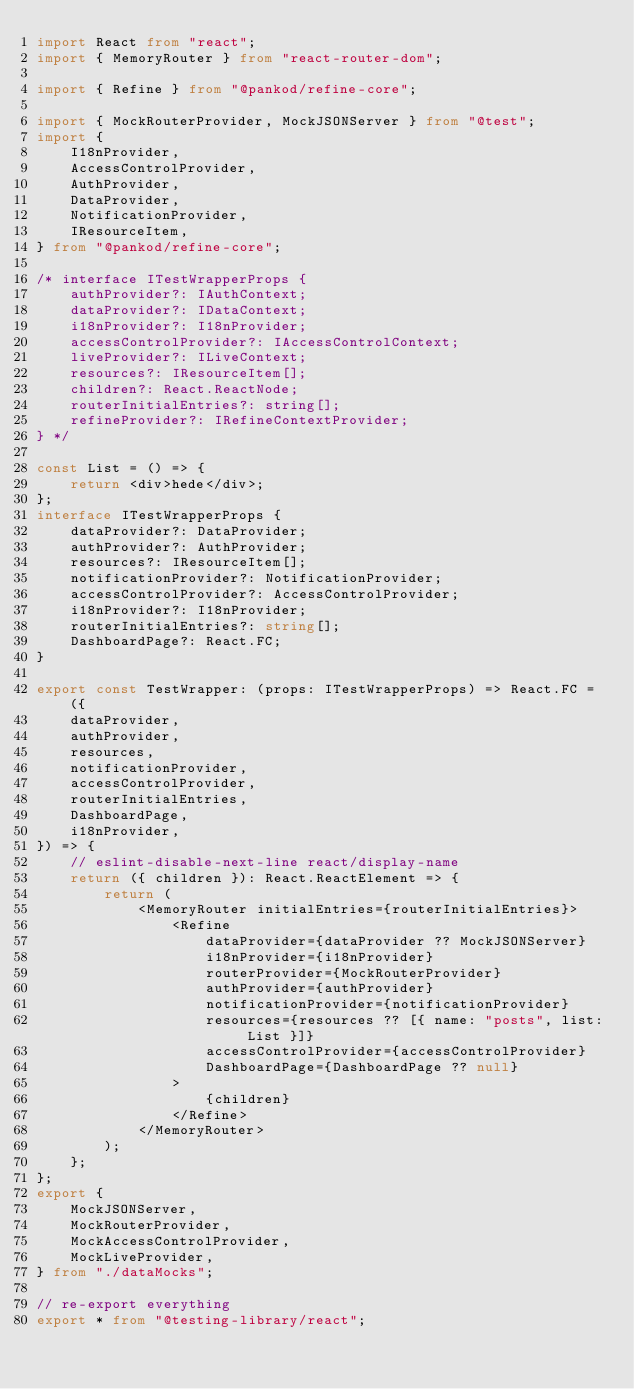<code> <loc_0><loc_0><loc_500><loc_500><_TypeScript_>import React from "react";
import { MemoryRouter } from "react-router-dom";

import { Refine } from "@pankod/refine-core";

import { MockRouterProvider, MockJSONServer } from "@test";
import {
    I18nProvider,
    AccessControlProvider,
    AuthProvider,
    DataProvider,
    NotificationProvider,
    IResourceItem,
} from "@pankod/refine-core";

/* interface ITestWrapperProps {
    authProvider?: IAuthContext;
    dataProvider?: IDataContext;
    i18nProvider?: I18nProvider;
    accessControlProvider?: IAccessControlContext;
    liveProvider?: ILiveContext;
    resources?: IResourceItem[];
    children?: React.ReactNode;
    routerInitialEntries?: string[];
    refineProvider?: IRefineContextProvider;
} */

const List = () => {
    return <div>hede</div>;
};
interface ITestWrapperProps {
    dataProvider?: DataProvider;
    authProvider?: AuthProvider;
    resources?: IResourceItem[];
    notificationProvider?: NotificationProvider;
    accessControlProvider?: AccessControlProvider;
    i18nProvider?: I18nProvider;
    routerInitialEntries?: string[];
    DashboardPage?: React.FC;
}

export const TestWrapper: (props: ITestWrapperProps) => React.FC = ({
    dataProvider,
    authProvider,
    resources,
    notificationProvider,
    accessControlProvider,
    routerInitialEntries,
    DashboardPage,
    i18nProvider,
}) => {
    // eslint-disable-next-line react/display-name
    return ({ children }): React.ReactElement => {
        return (
            <MemoryRouter initialEntries={routerInitialEntries}>
                <Refine
                    dataProvider={dataProvider ?? MockJSONServer}
                    i18nProvider={i18nProvider}
                    routerProvider={MockRouterProvider}
                    authProvider={authProvider}
                    notificationProvider={notificationProvider}
                    resources={resources ?? [{ name: "posts", list: List }]}
                    accessControlProvider={accessControlProvider}
                    DashboardPage={DashboardPage ?? null}
                >
                    {children}
                </Refine>
            </MemoryRouter>
        );
    };
};
export {
    MockJSONServer,
    MockRouterProvider,
    MockAccessControlProvider,
    MockLiveProvider,
} from "./dataMocks";

// re-export everything
export * from "@testing-library/react";
</code> 